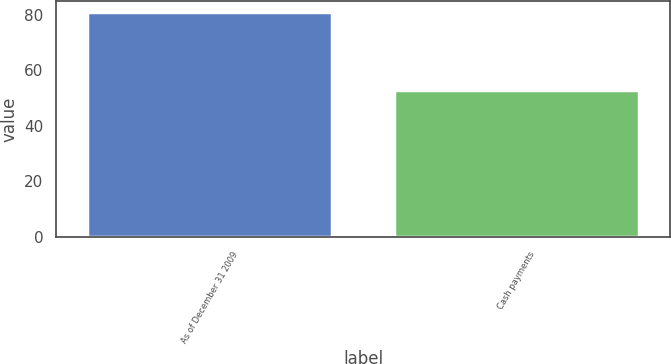<chart> <loc_0><loc_0><loc_500><loc_500><bar_chart><fcel>As of December 31 2009<fcel>Cash payments<nl><fcel>81<fcel>53<nl></chart> 